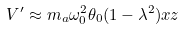<formula> <loc_0><loc_0><loc_500><loc_500>V ^ { \prime } \approx m _ { a } \omega _ { 0 } ^ { 2 } \theta _ { 0 } ( 1 - \lambda ^ { 2 } ) x z</formula> 